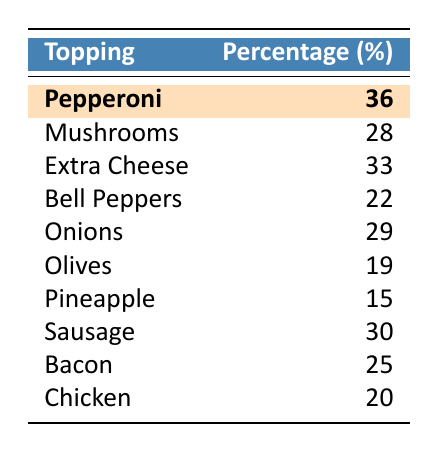What's the most popular pizza topping among 26-year-olds? The table indicates that Pepperoni has the highest percentage at 36%, making it the most popular topping.
Answer: 36% What percentage of people prefer mushrooms as a topping? Referring to the table, Mushrooms are preferred by 28% of the respondents.
Answer: 28% Is Extra Cheese more popular than Bacon among 26-year-olds? Extra Cheese is preferred by 33%, while Bacon is preferred by 25%. Therefore, Extra Cheese is more popular.
Answer: Yes What is the percentage difference between the preference for Sausage and Pineapple? Sausage is preferred by 30%, and Pineapple by 15%. The difference is 30% - 15% = 15%.
Answer: 15% What is the sum of percentages for Chicken and Olives? Chicken is at 20%, and Olives at 19%. Adding these gives 20% + 19% = 39%.
Answer: 39% Which topping has a percentage closest to the average topping preference for 26-year-olds? The average preference can be calculated as (36 + 28 + 33 + 22 + 29 + 19 + 15 + 30 + 25 + 20) / 10 = 25.7%. The closest topping is Bacon at 25%.
Answer: 25% Are any of the toppings preferred by less than 20%? Pineapple at 15% and Olives at 19% are both less than 20%, so yes.
Answer: Yes Which two toppings together have the highest combined preference? The highest individual preferences are Pepperoni at 36% and Extra Cheese at 33%. Adding these gives 69%.
Answer: 69% What percentage of respondents favor onions compared to mushrooms? Onions are preferred by 29%, which is higher than the 28% for Mushrooms, so Onions are favored more.
Answer: Yes If a pizza party serves toppings in proportion to these percentages, which topping will be served the least? Pineapple at 15% is the least preferred topping, so it will be served the least at the party.
Answer: Pineapple 